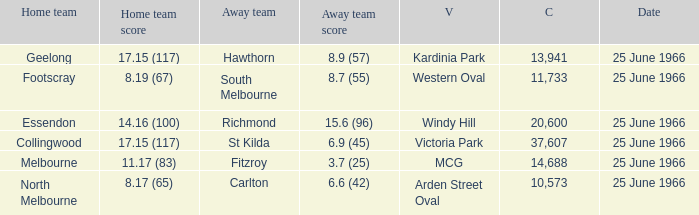What is the total crowd size when a home team scored 17.15 (117) versus hawthorn? 13941.0. 